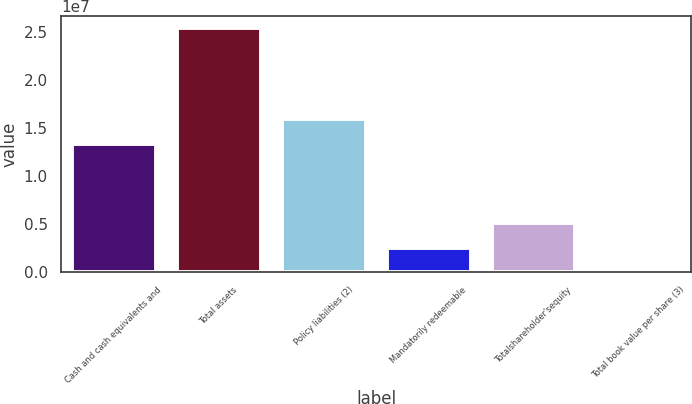<chart> <loc_0><loc_0><loc_500><loc_500><bar_chart><fcel>Cash and cash equivalents and<fcel>Total assets<fcel>Policy liabilities (2)<fcel>Mandatorily redeemable<fcel>Totalshareholder'sequity<fcel>Total book value per share (3)<nl><fcel>1.33714e+07<fcel>2.53655e+07<fcel>1.59079e+07<fcel>2.53657e+06<fcel>5.07311e+06<fcel>28.33<nl></chart> 